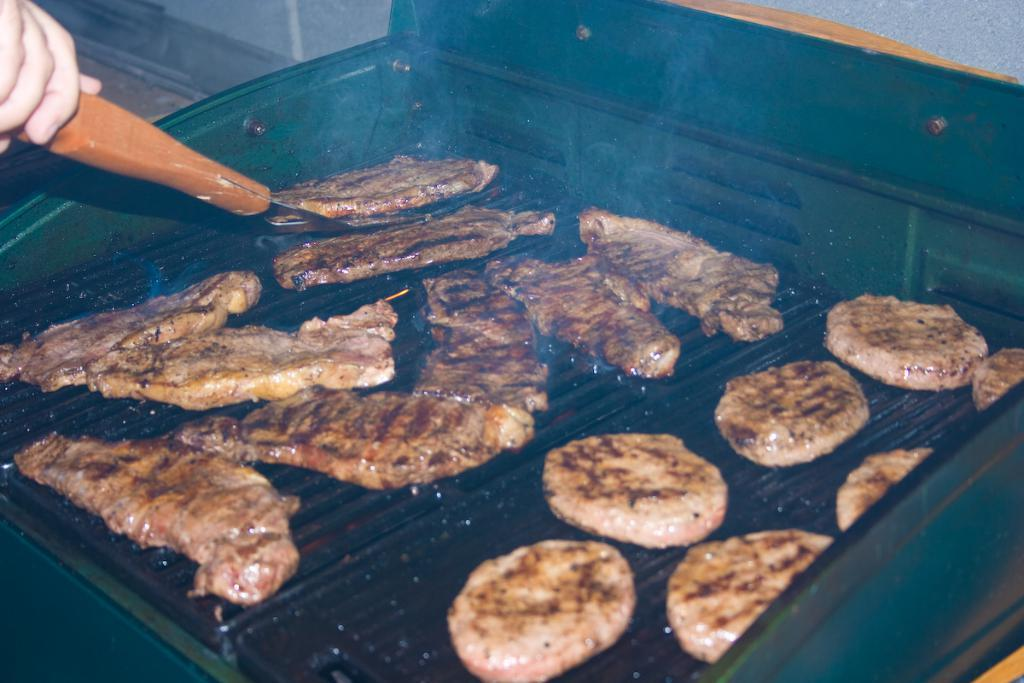What type of cooking appliance is in the image? There is a barbecue grill stove in the image. What is being cooked on the grill? There is meat on the grill. Whose hand is visible in the image? A person's hand is visible in the image. What object is the person holding in their hand? The person is holding a spoon in their hand. What type of popcorn is being prepared in the kettle in the image? There is no popcorn or kettle present in the image. 